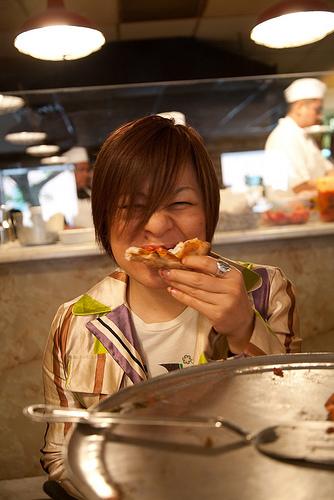What color is the man in the back wearing?
Concise answer only. White. Is the woman happy?
Keep it brief. Yes. What is the woman eating?
Quick response, please. Pizza. 